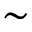Convert formula to latex. <formula><loc_0><loc_0><loc_500><loc_500>\sim</formula> 